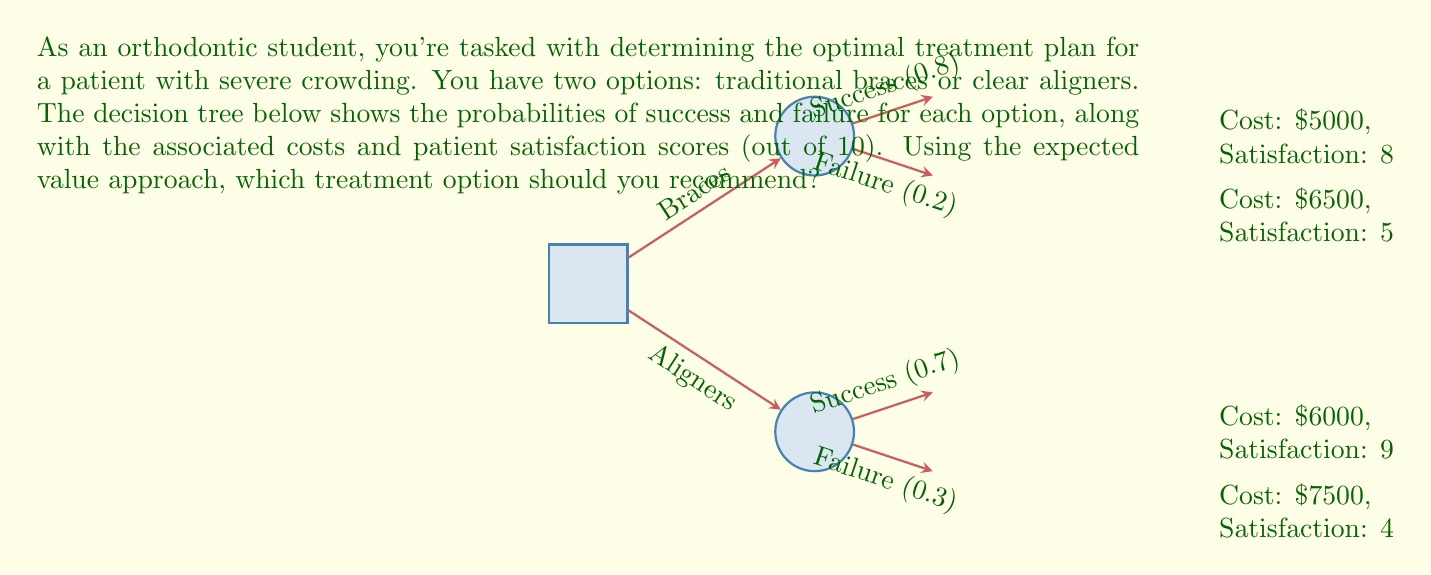Could you help me with this problem? To determine the optimal treatment plan using the expected value approach, we need to calculate the expected value for each option and compare them. We'll consider both cost and patient satisfaction in our calculations.

Step 1: Calculate the expected value for braces
Let's define a utility function that combines cost and satisfaction:
$U = -\text{Cost} + 1000 \times \text{Satisfaction}$

For braces:
Success: $U_s = -5000 + 1000 \times 8 = 3000$
Failure: $U_f = -6500 + 1000 \times 5 = -1500$

Expected Value for Braces:
$EV_{braces} = 0.8 \times 3000 + 0.2 \times (-1500) = 2100$

Step 2: Calculate the expected value for clear aligners
For clear aligners:
Success: $U_s = -6000 + 1000 \times 9 = 3000$
Failure: $U_f = -7500 + 1000 \times 4 = -3500$

Expected Value for Clear Aligners:
$EV_{aligners} = 0.7 \times 3000 + 0.3 \times (-3500) = 1050$

Step 3: Compare the expected values
$EV_{braces} = 2100 > EV_{aligners} = 1050$

Since the expected value for braces is higher, it is the optimal treatment plan according to this decision analysis.
Answer: Traditional braces 